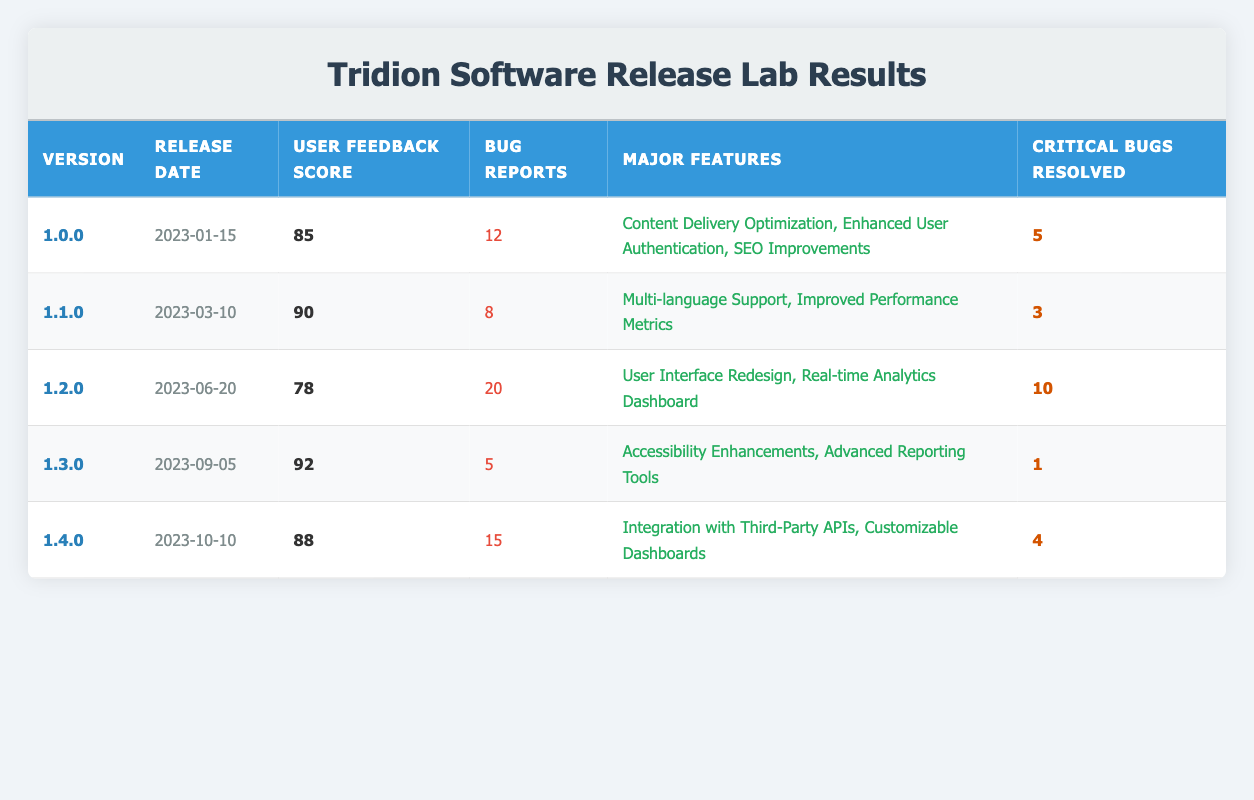What is the user feedback score for version 1.2.0? The user feedback score for version 1.2.0 can be found in the corresponding row. The score in the table for this version is 78.
Answer: 78 How many bug reports were filed for version 1.1.0? In the row for version 1.1.0, the number of bug reports is directly listed as 8.
Answer: 8 Which version had the highest user feedback score? By comparing the user feedback scores listed, version 1.3.0 has the highest score of 92.
Answer: 1.3.0 What is the average number of bug reports across all versions? The total number of bug reports is calculated by summing the values (12 + 8 + 20 + 5 + 15 = 60). Then, there are 5 versions, so the average is 60 divided by 5, which equals 12.
Answer: 12 Is it true that version 1.0.0 resolved more critical bugs than version 1.4.0? Looking at the critical bugs resolved for both versions, 1.0.0 resolved 5 critical bugs, while 1.4.0 resolved 4. Thus, it is true that version 1.0.0 resolved more critical bugs.
Answer: Yes What is the total number of critical bugs resolved in all versions? Add the critical bugs resolved from each version: (5 + 3 + 10 + 1 + 4 = 23). Therefore, the total is 23 critical bugs.
Answer: 23 Which version had the most major features? Analyzing the major features for each version, both version 1.0.0 and version 1.2.0 have 3 major features each. Thus, both versions are tied for the most major features.
Answer: 1.0.0 and 1.2.0 Did any version release date fall in the second quarter of 2023? The release date of version 1.2.0 is June 20, 2023, which is in the second quarter of the year. Therefore, it is true that at least one version fell in this period.
Answer: Yes What is the difference in user feedback scores between version 1.1.0 and version 1.4.0? Subtract the user feedback score of version 1.4.0 (88) from that of version 1.1.0 (90) to get the difference: 90 - 88 = 2.
Answer: 2 